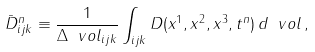<formula> <loc_0><loc_0><loc_500><loc_500>\bar { D } ^ { n } _ { i j k } \equiv \frac { 1 } { \Delta \ v o l _ { i j k } } \int _ { i j k } D ( x ^ { 1 } , x ^ { 2 } , x ^ { 3 } , t ^ { n } ) \, d \ v o l \, ,</formula> 